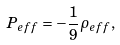<formula> <loc_0><loc_0><loc_500><loc_500>P _ { e f f } = - \frac { 1 } { 9 } \rho _ { e f f } ,</formula> 